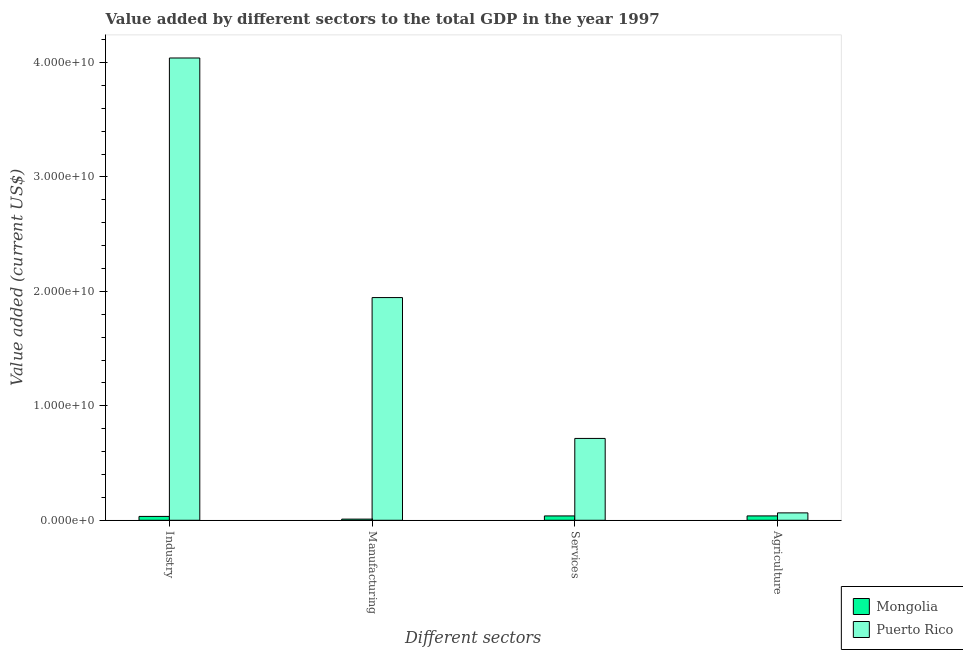How many groups of bars are there?
Offer a very short reply. 4. Are the number of bars on each tick of the X-axis equal?
Provide a succinct answer. Yes. How many bars are there on the 2nd tick from the right?
Make the answer very short. 2. What is the label of the 4th group of bars from the left?
Ensure brevity in your answer.  Agriculture. What is the value added by industrial sector in Puerto Rico?
Your answer should be very brief. 4.04e+1. Across all countries, what is the maximum value added by agricultural sector?
Offer a very short reply. 6.45e+08. Across all countries, what is the minimum value added by industrial sector?
Offer a terse response. 3.37e+08. In which country was the value added by agricultural sector maximum?
Make the answer very short. Puerto Rico. In which country was the value added by manufacturing sector minimum?
Provide a short and direct response. Mongolia. What is the total value added by manufacturing sector in the graph?
Your answer should be compact. 1.96e+1. What is the difference between the value added by industrial sector in Puerto Rico and that in Mongolia?
Your response must be concise. 4.01e+1. What is the difference between the value added by industrial sector in Puerto Rico and the value added by manufacturing sector in Mongolia?
Keep it short and to the point. 4.03e+1. What is the average value added by agricultural sector per country?
Provide a succinct answer. 5.13e+08. What is the difference between the value added by services sector and value added by industrial sector in Puerto Rico?
Your response must be concise. -3.32e+1. What is the ratio of the value added by industrial sector in Mongolia to that in Puerto Rico?
Offer a terse response. 0.01. What is the difference between the highest and the second highest value added by manufacturing sector?
Give a very brief answer. 1.94e+1. What is the difference between the highest and the lowest value added by agricultural sector?
Ensure brevity in your answer.  2.65e+08. Is the sum of the value added by agricultural sector in Puerto Rico and Mongolia greater than the maximum value added by industrial sector across all countries?
Keep it short and to the point. No. What does the 1st bar from the left in Manufacturing represents?
Provide a succinct answer. Mongolia. What does the 1st bar from the right in Manufacturing represents?
Ensure brevity in your answer.  Puerto Rico. How many bars are there?
Keep it short and to the point. 8. Are all the bars in the graph horizontal?
Keep it short and to the point. No. How many countries are there in the graph?
Offer a very short reply. 2. Are the values on the major ticks of Y-axis written in scientific E-notation?
Keep it short and to the point. Yes. Does the graph contain any zero values?
Keep it short and to the point. No. Does the graph contain grids?
Ensure brevity in your answer.  No. How are the legend labels stacked?
Provide a short and direct response. Vertical. What is the title of the graph?
Your response must be concise. Value added by different sectors to the total GDP in the year 1997. What is the label or title of the X-axis?
Provide a short and direct response. Different sectors. What is the label or title of the Y-axis?
Ensure brevity in your answer.  Value added (current US$). What is the Value added (current US$) in Mongolia in Industry?
Offer a very short reply. 3.37e+08. What is the Value added (current US$) of Puerto Rico in Industry?
Ensure brevity in your answer.  4.04e+1. What is the Value added (current US$) in Mongolia in Manufacturing?
Give a very brief answer. 9.99e+07. What is the Value added (current US$) in Puerto Rico in Manufacturing?
Give a very brief answer. 1.95e+1. What is the Value added (current US$) of Mongolia in Services?
Provide a succinct answer. 3.79e+08. What is the Value added (current US$) in Puerto Rico in Services?
Give a very brief answer. 7.15e+09. What is the Value added (current US$) in Mongolia in Agriculture?
Provide a succinct answer. 3.81e+08. What is the Value added (current US$) of Puerto Rico in Agriculture?
Give a very brief answer. 6.45e+08. Across all Different sectors, what is the maximum Value added (current US$) of Mongolia?
Give a very brief answer. 3.81e+08. Across all Different sectors, what is the maximum Value added (current US$) of Puerto Rico?
Give a very brief answer. 4.04e+1. Across all Different sectors, what is the minimum Value added (current US$) in Mongolia?
Make the answer very short. 9.99e+07. Across all Different sectors, what is the minimum Value added (current US$) in Puerto Rico?
Offer a terse response. 6.45e+08. What is the total Value added (current US$) in Mongolia in the graph?
Your response must be concise. 1.20e+09. What is the total Value added (current US$) in Puerto Rico in the graph?
Your response must be concise. 6.76e+1. What is the difference between the Value added (current US$) in Mongolia in Industry and that in Manufacturing?
Your answer should be compact. 2.37e+08. What is the difference between the Value added (current US$) in Puerto Rico in Industry and that in Manufacturing?
Give a very brief answer. 2.09e+1. What is the difference between the Value added (current US$) of Mongolia in Industry and that in Services?
Your answer should be very brief. -4.19e+07. What is the difference between the Value added (current US$) of Puerto Rico in Industry and that in Services?
Provide a short and direct response. 3.32e+1. What is the difference between the Value added (current US$) of Mongolia in Industry and that in Agriculture?
Your answer should be compact. -4.38e+07. What is the difference between the Value added (current US$) in Puerto Rico in Industry and that in Agriculture?
Your answer should be very brief. 3.97e+1. What is the difference between the Value added (current US$) in Mongolia in Manufacturing and that in Services?
Make the answer very short. -2.79e+08. What is the difference between the Value added (current US$) in Puerto Rico in Manufacturing and that in Services?
Make the answer very short. 1.23e+1. What is the difference between the Value added (current US$) of Mongolia in Manufacturing and that in Agriculture?
Your response must be concise. -2.81e+08. What is the difference between the Value added (current US$) in Puerto Rico in Manufacturing and that in Agriculture?
Ensure brevity in your answer.  1.88e+1. What is the difference between the Value added (current US$) in Mongolia in Services and that in Agriculture?
Provide a succinct answer. -1.99e+06. What is the difference between the Value added (current US$) of Puerto Rico in Services and that in Agriculture?
Provide a succinct answer. 6.50e+09. What is the difference between the Value added (current US$) of Mongolia in Industry and the Value added (current US$) of Puerto Rico in Manufacturing?
Provide a succinct answer. -1.91e+1. What is the difference between the Value added (current US$) of Mongolia in Industry and the Value added (current US$) of Puerto Rico in Services?
Your answer should be compact. -6.81e+09. What is the difference between the Value added (current US$) in Mongolia in Industry and the Value added (current US$) in Puerto Rico in Agriculture?
Ensure brevity in your answer.  -3.08e+08. What is the difference between the Value added (current US$) in Mongolia in Manufacturing and the Value added (current US$) in Puerto Rico in Services?
Your answer should be very brief. -7.05e+09. What is the difference between the Value added (current US$) of Mongolia in Manufacturing and the Value added (current US$) of Puerto Rico in Agriculture?
Ensure brevity in your answer.  -5.45e+08. What is the difference between the Value added (current US$) in Mongolia in Services and the Value added (current US$) in Puerto Rico in Agriculture?
Keep it short and to the point. -2.67e+08. What is the average Value added (current US$) in Mongolia per Different sectors?
Keep it short and to the point. 2.99e+08. What is the average Value added (current US$) of Puerto Rico per Different sectors?
Provide a short and direct response. 1.69e+1. What is the difference between the Value added (current US$) in Mongolia and Value added (current US$) in Puerto Rico in Industry?
Provide a short and direct response. -4.01e+1. What is the difference between the Value added (current US$) of Mongolia and Value added (current US$) of Puerto Rico in Manufacturing?
Ensure brevity in your answer.  -1.94e+1. What is the difference between the Value added (current US$) in Mongolia and Value added (current US$) in Puerto Rico in Services?
Provide a short and direct response. -6.77e+09. What is the difference between the Value added (current US$) of Mongolia and Value added (current US$) of Puerto Rico in Agriculture?
Offer a very short reply. -2.65e+08. What is the ratio of the Value added (current US$) in Mongolia in Industry to that in Manufacturing?
Your answer should be very brief. 3.37. What is the ratio of the Value added (current US$) of Puerto Rico in Industry to that in Manufacturing?
Your response must be concise. 2.08. What is the ratio of the Value added (current US$) of Mongolia in Industry to that in Services?
Provide a short and direct response. 0.89. What is the ratio of the Value added (current US$) in Puerto Rico in Industry to that in Services?
Provide a short and direct response. 5.65. What is the ratio of the Value added (current US$) of Mongolia in Industry to that in Agriculture?
Your answer should be compact. 0.88. What is the ratio of the Value added (current US$) in Puerto Rico in Industry to that in Agriculture?
Make the answer very short. 62.59. What is the ratio of the Value added (current US$) in Mongolia in Manufacturing to that in Services?
Provide a short and direct response. 0.26. What is the ratio of the Value added (current US$) of Puerto Rico in Manufacturing to that in Services?
Provide a short and direct response. 2.72. What is the ratio of the Value added (current US$) in Mongolia in Manufacturing to that in Agriculture?
Offer a very short reply. 0.26. What is the ratio of the Value added (current US$) of Puerto Rico in Manufacturing to that in Agriculture?
Your answer should be compact. 30.15. What is the ratio of the Value added (current US$) in Puerto Rico in Services to that in Agriculture?
Offer a terse response. 11.08. What is the difference between the highest and the second highest Value added (current US$) of Mongolia?
Offer a terse response. 1.99e+06. What is the difference between the highest and the second highest Value added (current US$) of Puerto Rico?
Your response must be concise. 2.09e+1. What is the difference between the highest and the lowest Value added (current US$) of Mongolia?
Make the answer very short. 2.81e+08. What is the difference between the highest and the lowest Value added (current US$) of Puerto Rico?
Your answer should be very brief. 3.97e+1. 